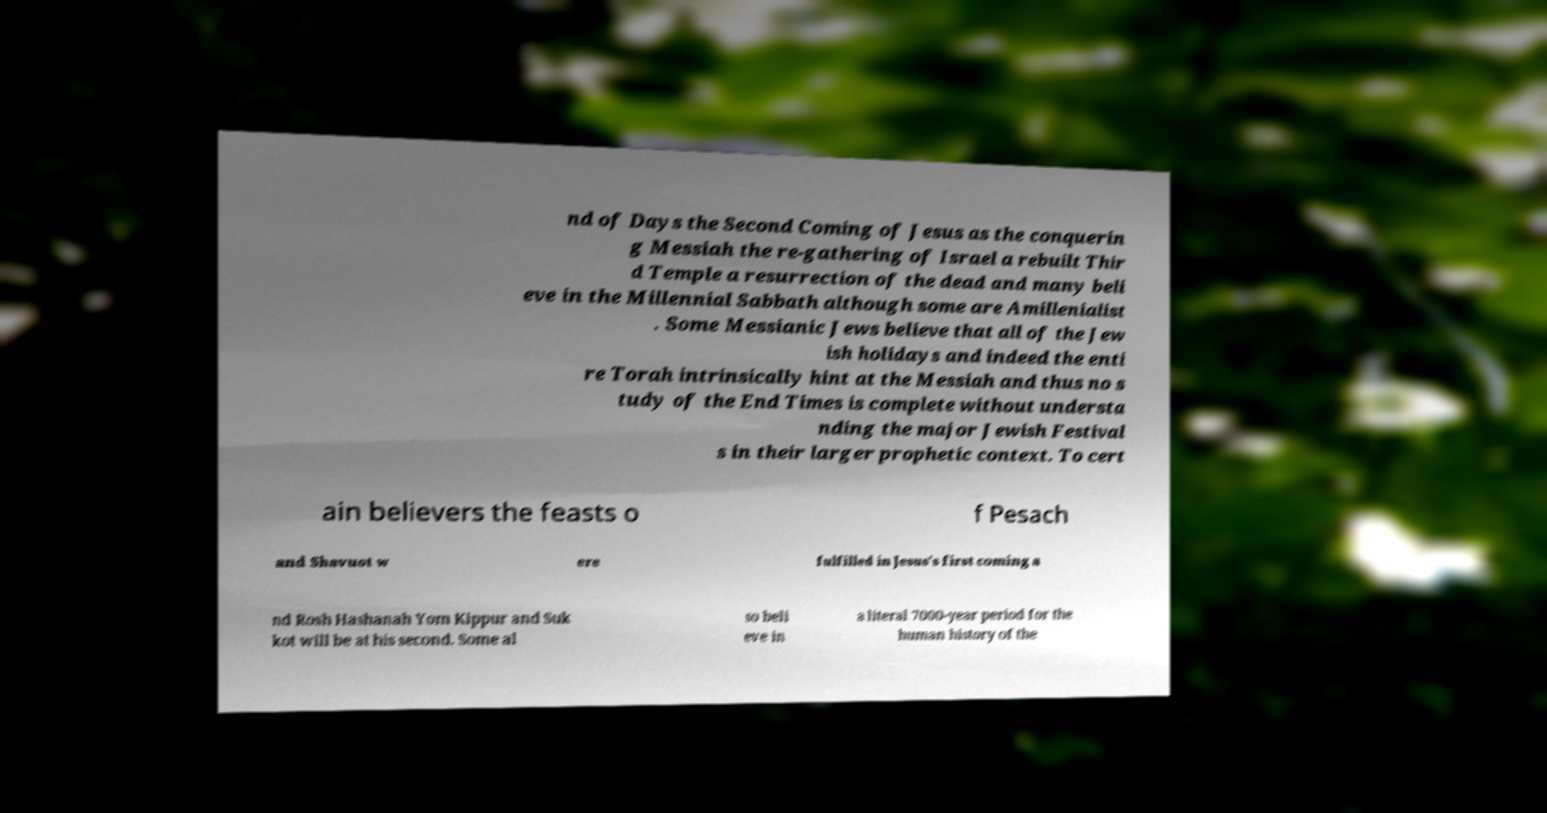Can you read and provide the text displayed in the image?This photo seems to have some interesting text. Can you extract and type it out for me? nd of Days the Second Coming of Jesus as the conquerin g Messiah the re-gathering of Israel a rebuilt Thir d Temple a resurrection of the dead and many beli eve in the Millennial Sabbath although some are Amillenialist . Some Messianic Jews believe that all of the Jew ish holidays and indeed the enti re Torah intrinsically hint at the Messiah and thus no s tudy of the End Times is complete without understa nding the major Jewish Festival s in their larger prophetic context. To cert ain believers the feasts o f Pesach and Shavuot w ere fulfilled in Jesus's first coming a nd Rosh Hashanah Yom Kippur and Suk kot will be at his second. Some al so beli eve in a literal 7000-year period for the human history of the 